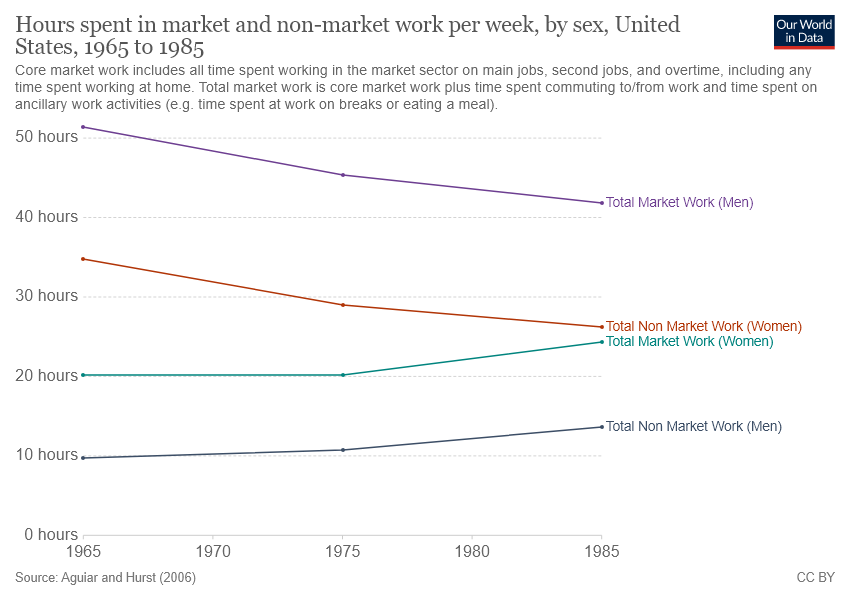Point out several critical features in this image. In 1965, the base year, the graph shows that the line for "Total Non-Market Work (Men)" is moving upwards. 